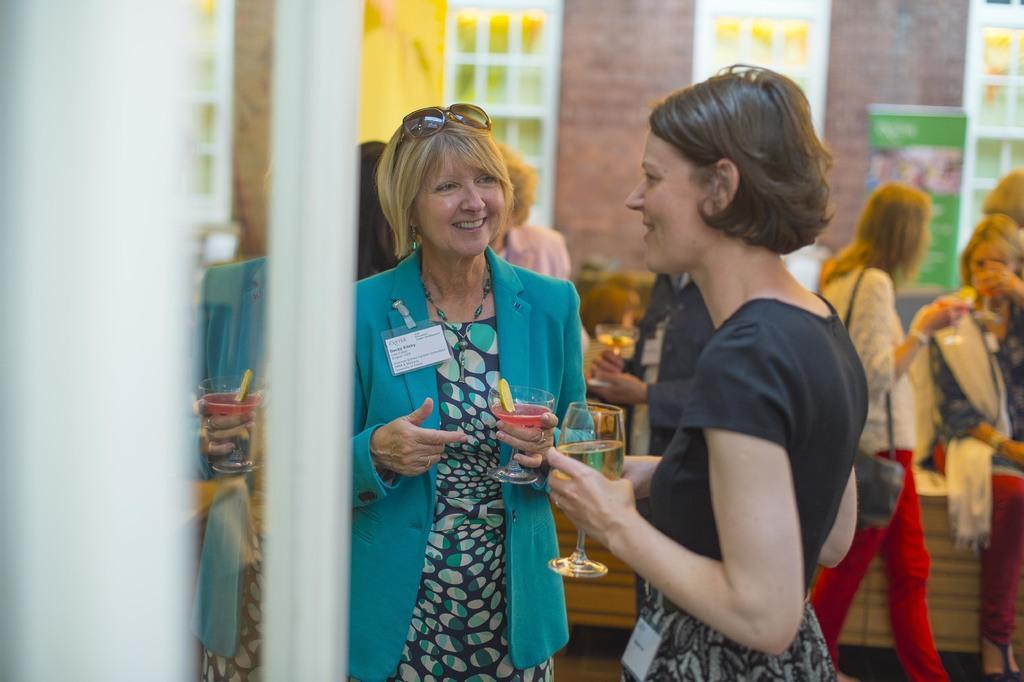In one or two sentences, can you explain what this image depicts? In this image there are two women who are standing in the middle by holding the glasses. In the background there are few other women who are sitting and drinking the drink. In the background there is a wall to which there are windows. On the left side there is a mirror. 